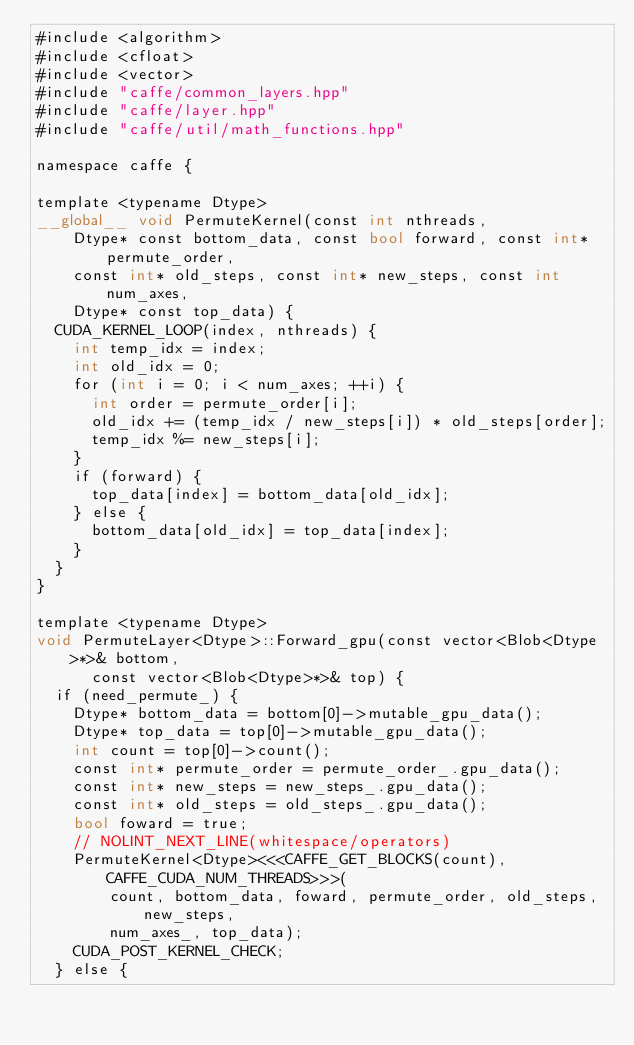Convert code to text. <code><loc_0><loc_0><loc_500><loc_500><_Cuda_>#include <algorithm>
#include <cfloat>
#include <vector>
#include "caffe/common_layers.hpp"
#include "caffe/layer.hpp"
#include "caffe/util/math_functions.hpp"

namespace caffe {

template <typename Dtype>
__global__ void PermuteKernel(const int nthreads,
    Dtype* const bottom_data, const bool forward, const int* permute_order,
    const int* old_steps, const int* new_steps, const int num_axes,
    Dtype* const top_data) {
  CUDA_KERNEL_LOOP(index, nthreads) {
    int temp_idx = index;
    int old_idx = 0;
    for (int i = 0; i < num_axes; ++i) {
      int order = permute_order[i];
      old_idx += (temp_idx / new_steps[i]) * old_steps[order];
      temp_idx %= new_steps[i];
    }
    if (forward) {
      top_data[index] = bottom_data[old_idx];
    } else {
      bottom_data[old_idx] = top_data[index];
    }
  }
}

template <typename Dtype>
void PermuteLayer<Dtype>::Forward_gpu(const vector<Blob<Dtype>*>& bottom,
      const vector<Blob<Dtype>*>& top) {
  if (need_permute_) {
    Dtype* bottom_data = bottom[0]->mutable_gpu_data();
    Dtype* top_data = top[0]->mutable_gpu_data();
    int count = top[0]->count();
    const int* permute_order = permute_order_.gpu_data();
    const int* new_steps = new_steps_.gpu_data();
    const int* old_steps = old_steps_.gpu_data();
    bool foward = true;
    // NOLINT_NEXT_LINE(whitespace/operators)
    PermuteKernel<Dtype><<<CAFFE_GET_BLOCKS(count), CAFFE_CUDA_NUM_THREADS>>>(
        count, bottom_data, foward, permute_order, old_steps, new_steps,
        num_axes_, top_data);
    CUDA_POST_KERNEL_CHECK;
  } else {</code> 